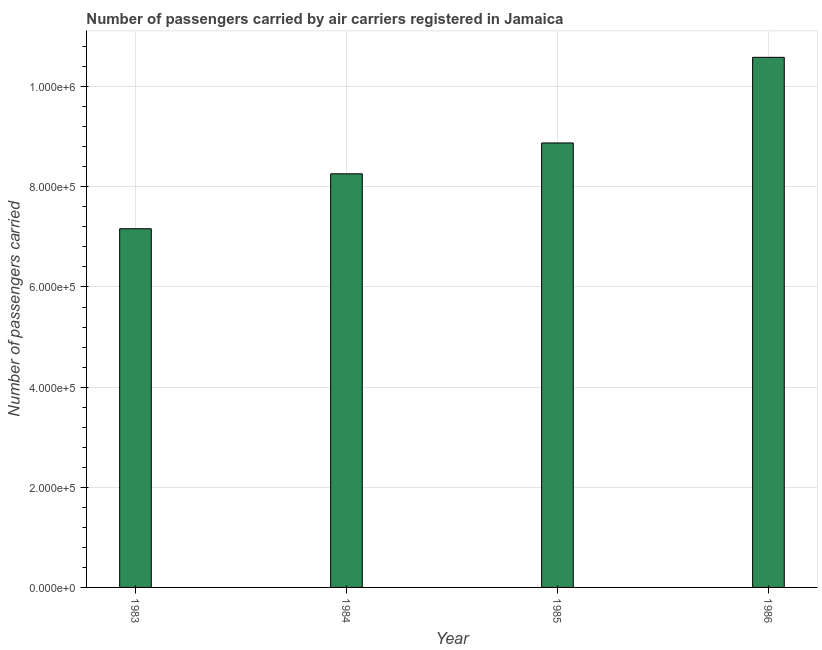What is the title of the graph?
Offer a very short reply. Number of passengers carried by air carriers registered in Jamaica. What is the label or title of the X-axis?
Your response must be concise. Year. What is the label or title of the Y-axis?
Keep it short and to the point. Number of passengers carried. What is the number of passengers carried in 1984?
Give a very brief answer. 8.26e+05. Across all years, what is the maximum number of passengers carried?
Keep it short and to the point. 1.06e+06. Across all years, what is the minimum number of passengers carried?
Your response must be concise. 7.16e+05. In which year was the number of passengers carried maximum?
Offer a terse response. 1986. In which year was the number of passengers carried minimum?
Keep it short and to the point. 1983. What is the sum of the number of passengers carried?
Provide a succinct answer. 3.49e+06. What is the difference between the number of passengers carried in 1984 and 1985?
Provide a succinct answer. -6.16e+04. What is the average number of passengers carried per year?
Give a very brief answer. 8.72e+05. What is the median number of passengers carried?
Provide a succinct answer. 8.57e+05. In how many years, is the number of passengers carried greater than 600000 ?
Offer a very short reply. 4. What is the ratio of the number of passengers carried in 1985 to that in 1986?
Offer a very short reply. 0.84. Is the number of passengers carried in 1985 less than that in 1986?
Provide a short and direct response. Yes. Is the difference between the number of passengers carried in 1983 and 1986 greater than the difference between any two years?
Offer a terse response. Yes. What is the difference between the highest and the second highest number of passengers carried?
Offer a very short reply. 1.71e+05. Is the sum of the number of passengers carried in 1985 and 1986 greater than the maximum number of passengers carried across all years?
Keep it short and to the point. Yes. What is the difference between the highest and the lowest number of passengers carried?
Ensure brevity in your answer.  3.42e+05. How many years are there in the graph?
Offer a terse response. 4. What is the difference between two consecutive major ticks on the Y-axis?
Your response must be concise. 2.00e+05. Are the values on the major ticks of Y-axis written in scientific E-notation?
Your answer should be compact. Yes. What is the Number of passengers carried in 1983?
Make the answer very short. 7.16e+05. What is the Number of passengers carried in 1984?
Provide a short and direct response. 8.26e+05. What is the Number of passengers carried in 1985?
Your response must be concise. 8.88e+05. What is the Number of passengers carried of 1986?
Provide a short and direct response. 1.06e+06. What is the difference between the Number of passengers carried in 1983 and 1984?
Your response must be concise. -1.10e+05. What is the difference between the Number of passengers carried in 1983 and 1985?
Your response must be concise. -1.71e+05. What is the difference between the Number of passengers carried in 1983 and 1986?
Keep it short and to the point. -3.42e+05. What is the difference between the Number of passengers carried in 1984 and 1985?
Make the answer very short. -6.16e+04. What is the difference between the Number of passengers carried in 1984 and 1986?
Offer a terse response. -2.33e+05. What is the difference between the Number of passengers carried in 1985 and 1986?
Keep it short and to the point. -1.71e+05. What is the ratio of the Number of passengers carried in 1983 to that in 1984?
Provide a short and direct response. 0.87. What is the ratio of the Number of passengers carried in 1983 to that in 1985?
Make the answer very short. 0.81. What is the ratio of the Number of passengers carried in 1983 to that in 1986?
Offer a very short reply. 0.68. What is the ratio of the Number of passengers carried in 1984 to that in 1986?
Your response must be concise. 0.78. What is the ratio of the Number of passengers carried in 1985 to that in 1986?
Give a very brief answer. 0.84. 